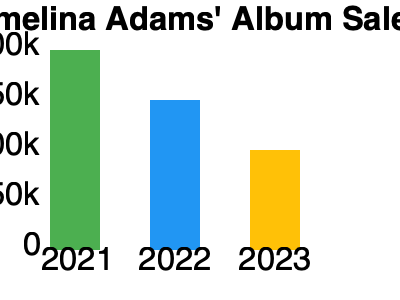Based on the bar chart showing Emelina Adams' album sales from 2021 to 2023, what is the total number of albums sold over the three-year period? To calculate the total number of albums sold over the three-year period, we need to sum up the sales for each year:

1. 2021 sales: The bar reaches the 200k mark, so the sales were 200,000 albums.
2. 2022 sales: The bar reaches the 150k mark, so the sales were 150,000 albums.
3. 2023 sales: The bar reaches the 100k mark, so the sales were 100,000 albums.

Now, let's add these numbers:

$200,000 + 150,000 + 100,000 = 450,000$

Therefore, the total number of albums sold over the three-year period is 450,000.
Answer: 450,000 albums 